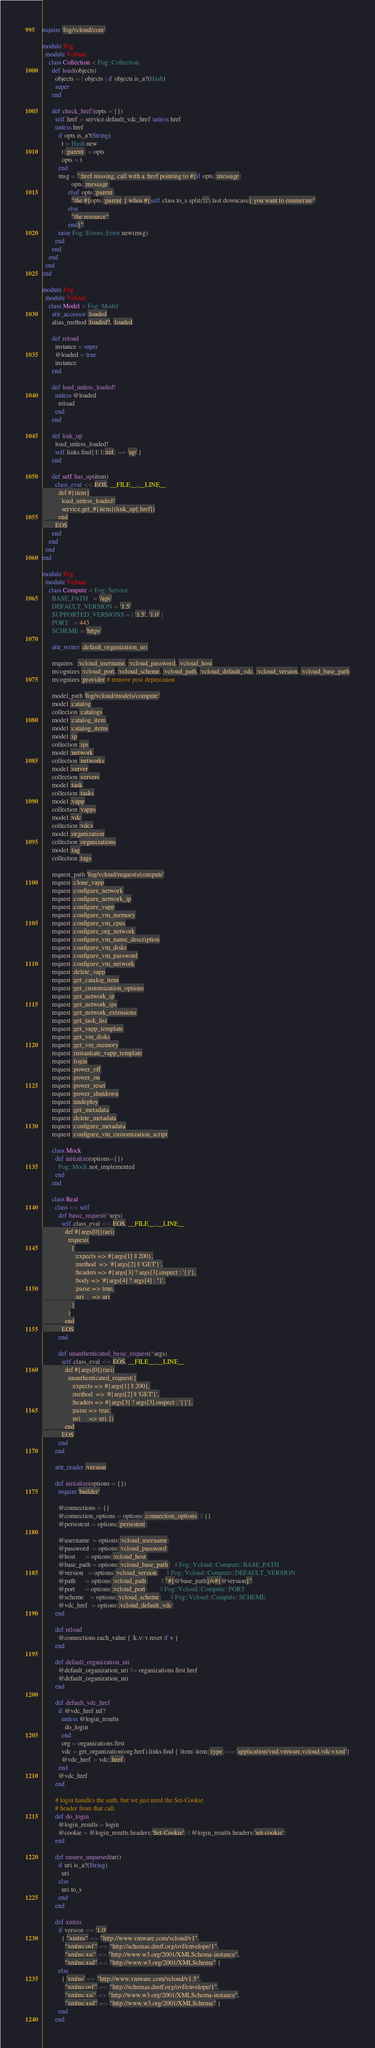Convert code to text. <code><loc_0><loc_0><loc_500><loc_500><_Ruby_>require 'fog/vcloud/core'

module Fog
  module Vcloud
    class Collection < Fog::Collection
      def load(objects)
        objects = [ objects ] if objects.is_a?(Hash)
        super
      end

      def check_href!(opts = {})
        self.href = service.default_vdc_href unless href
        unless href
          if opts.is_a?(String)
            t = Hash.new
            t[:parent] = opts
            opts = t
          end
          msg = ":href missing, call with a :href pointing to #{if opts[:message]
                  opts[:message]
                elsif opts[:parent]
                  "the #{opts[:parent]} whos #{self.class.to_s.split('::').last.downcase} you want to enumerate"
                else
                  "the resource"
                end}"
          raise Fog::Errors::Error.new(msg)
        end
      end
    end
  end
end

module Fog
  module Vcloud
    class Model < Fog::Model
      attr_accessor :loaded
      alias_method :loaded?, :loaded

      def reload
        instance = super
        @loaded = true
        instance
      end

      def load_unless_loaded!
        unless @loaded
          reload
        end
      end

      def link_up
        load_unless_loaded!
        self.links.find{|l| l[:rel] == 'up' }
      end

      def self.has_up(item)
        class_eval <<-EOS, __FILE__,__LINE__
          def #{item}
            load_unless_loaded!
            service.get_#{item}(link_up[:href])
          end
        EOS
      end
    end
  end
end

module Fog
  module Vcloud
    class Compute < Fog::Service
      BASE_PATH   = '/api'
      DEFAULT_VERSION = '1.5'
      SUPPORTED_VERSIONS = [ '1.5', '1.0' ]
      PORT   = 443
      SCHEME = 'https'

      attr_writer :default_organization_uri

      requires   :vcloud_username, :vcloud_password, :vcloud_host
      recognizes :vcloud_port, :vcloud_scheme, :vcloud_path, :vcloud_default_vdc, :vcloud_version, :vcloud_base_path
      recognizes :provider # remove post deprecation

      model_path 'fog/vcloud/models/compute'
      model :catalog
      collection :catalogs
      model :catalog_item
      model :catalog_items
      model :ip
      collection :ips
      model :network
      collection :networks
      model :server
      collection :servers
      model :task
      collection :tasks
      model :vapp
      collection :vapps
      model :vdc
      collection :vdcs
      model :organization
      collection :organizations
      model :tag
      collection :tags

      request_path 'fog/vcloud/requests/compute'
      request :clone_vapp
      request :configure_network
      request :configure_network_ip
      request :configure_vapp
      request :configure_vm_memory
      request :configure_vm_cpus
      request :configure_org_network
      request :configure_vm_name_description
      request :configure_vm_disks
      request :configure_vm_password
      request :configure_vm_network
      request :delete_vapp
      request :get_catalog_item
      request :get_customization_options
      request :get_network_ip
      request :get_network_ips
      request :get_network_extensions
      request :get_task_list
      request :get_vapp_template
      request :get_vm_disks
      request :get_vm_memory
      request :instantiate_vapp_template
      request :login
      request :power_off
      request :power_on
      request :power_reset
      request :power_shutdown
      request :undeploy
      request :get_metadata
      request :delete_metadata
      request :configure_metadata
      request :configure_vm_customization_script

      class Mock
        def initialize(options={})
          Fog::Mock.not_implemented
        end
      end

      class Real
        class << self
          def basic_request(*args)
            self.class_eval <<-EOS, __FILE__,__LINE__
              def #{args[0]}(uri)
                request(
                  {
                    :expects => #{args[1] || 200},
                    :method  => '#{args[2] || 'GET'}',
                    :headers => #{args[3] ? args[3].inspect : '{}'},
                    :body => '#{args[4] ? args[4] : ''}',
                    :parse => true,
                    :uri     => uri
                  }
                )
              end
            EOS
          end

          def unauthenticated_basic_request(*args)
            self.class_eval <<-EOS, __FILE__,__LINE__
              def #{args[0]}(uri)
                unauthenticated_request({
                  :expects => #{args[1] || 200},
                  :method  => '#{args[2] || 'GET'}',
                  :headers => #{args[3] ? args[3].inspect : '{}'},
                  :parse => true,
                  :uri     => uri })
              end
            EOS
          end
        end

        attr_reader :version

        def initialize(options = {})
          require 'builder'

          @connections = {}
          @connection_options = options[:connection_options] || {}
          @persistent = options[:persistent]

          @username  = options[:vcloud_username]
          @password  = options[:vcloud_password]
          @host      = options[:vcloud_host]
          @base_path = options[:vcloud_base_path]   || Fog::Vcloud::Compute::BASE_PATH
          @version   = options[:vcloud_version]     || Fog::Vcloud::Compute::DEFAULT_VERSION
          @path      = options[:vcloud_path]        || "#{@base_path}/v#{@version}"
          @port      = options[:vcloud_port]        || Fog::Vcloud::Compute::PORT
          @scheme    = options[:vcloud_scheme]      || Fog::Vcloud::Compute::SCHEME
          @vdc_href  = options[:vcloud_default_vdc]
        end

        def reload
          @connections.each_value { |k,v| v.reset if v }
        end

        def default_organization_uri
          @default_organization_uri ||= organizations.first.href
          @default_organization_uri
        end

        def default_vdc_href
          if @vdc_href.nil?
            unless @login_results
              do_login
            end
            org = organizations.first
            vdc = get_organization(org.href).links.find { |item| item[:type] == 'application/vnd.vmware.vcloud.vdc+xml'}
            @vdc_href = vdc[:href]
          end
          @vdc_href
        end

        # login handles the auth, but we just need the Set-Cookie
        # header from that call.
        def do_login
          @login_results = login
          @cookie = @login_results.headers['Set-Cookie'] || @login_results.headers['set-cookie']
        end

        def ensure_unparsed(uri)
          if uri.is_a?(String)
            uri
          else
            uri.to_s
          end
        end

        def xmlns
          if version == '1.0'
            { "xmlns" => "http://www.vmware.com/vcloud/v1",
              "xmlns:ovf" => "http://schemas.dmtf.org/ovf/envelope/1",
              "xmlns:xsi" => "http://www.w3.org/2001/XMLSchema-instance",
              "xmlns:xsd" => "http://www.w3.org/2001/XMLSchema" }
          else
            { 'xmlns' => "http://www.vmware.com/vcloud/v1.5",
              "xmlns:ovf" => "http://schemas.dmtf.org/ovf/envelope/1",
              "xmlns:xsi" => "http://www.w3.org/2001/XMLSchema-instance",
              "xmlns:xsd" => "http://www.w3.org/2001/XMLSchema" }
          end
        end
</code> 